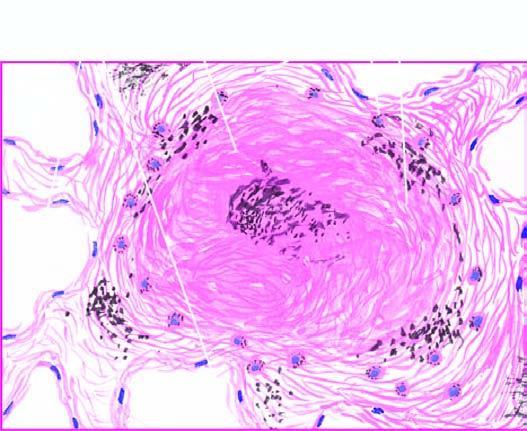what consists of hyaline centre surrounded by concentric layers of collagen which are further enclosed by fibroblasts and dust-laden macrophages?
Answer the question using a single word or phrase. Silicotic nodule 